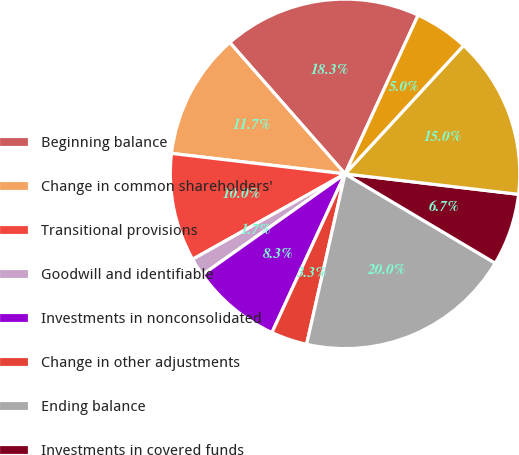Convert chart to OTSL. <chart><loc_0><loc_0><loc_500><loc_500><pie_chart><fcel>Beginning balance<fcel>Change in common shareholders'<fcel>Transitional provisions<fcel>Goodwill and identifiable<fcel>Investments in nonconsolidated<fcel>Change in other adjustments<fcel>Ending balance<fcel>Investments in covered funds<fcel>Other net increase in CET1<fcel>Redesignation of junior<nl><fcel>18.33%<fcel>11.67%<fcel>10.0%<fcel>1.67%<fcel>8.33%<fcel>3.34%<fcel>19.99%<fcel>6.67%<fcel>15.0%<fcel>5.0%<nl></chart> 